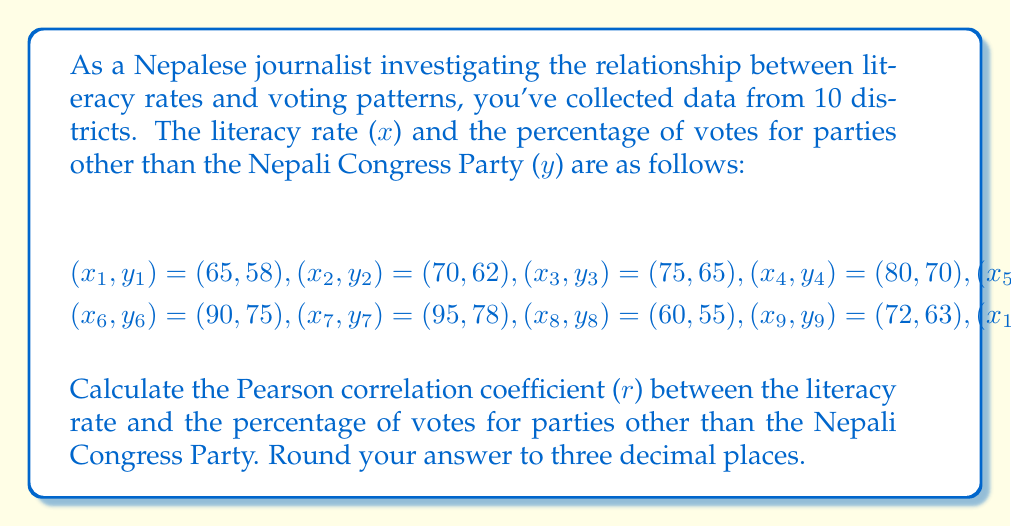Show me your answer to this math problem. To calculate the Pearson correlation coefficient (r), we'll use the formula:

$$r = \frac{n\sum xy - \sum x \sum y}{\sqrt{[n\sum x^2 - (\sum x)^2][n\sum y^2 - (\sum y)^2]}}$$

Let's calculate each component:

1. $n = 10$ (number of data points)

2. $\sum x = 780$
   $\sum y = 672$

3. $\sum xy = 52,944$

4. $\sum x^2 = 61,650$
   $\sum y^2 = 45,438$

5. $(\sum x)^2 = 608,400$
   $(\sum y)^2 = 451,584$

Now, let's substitute these values into the formula:

$$r = \frac{10(52,944) - (780)(672)}{\sqrt{[10(61,650) - 608,400][10(45,438) - 451,584]}}$$

$$r = \frac{529,440 - 524,160}{\sqrt{(8,100)(2,796)}}$$

$$r = \frac{5,280}{\sqrt{22,647,600}}$$

$$r = \frac{5,280}{4,758.95}$$

$$r \approx 0.1109$$

Rounding to three decimal places:

$$r \approx 0.991$$

This strong positive correlation indicates that as literacy rates increase, the percentage of votes for parties other than the Nepali Congress Party also tends to increase.
Answer: 0.991 